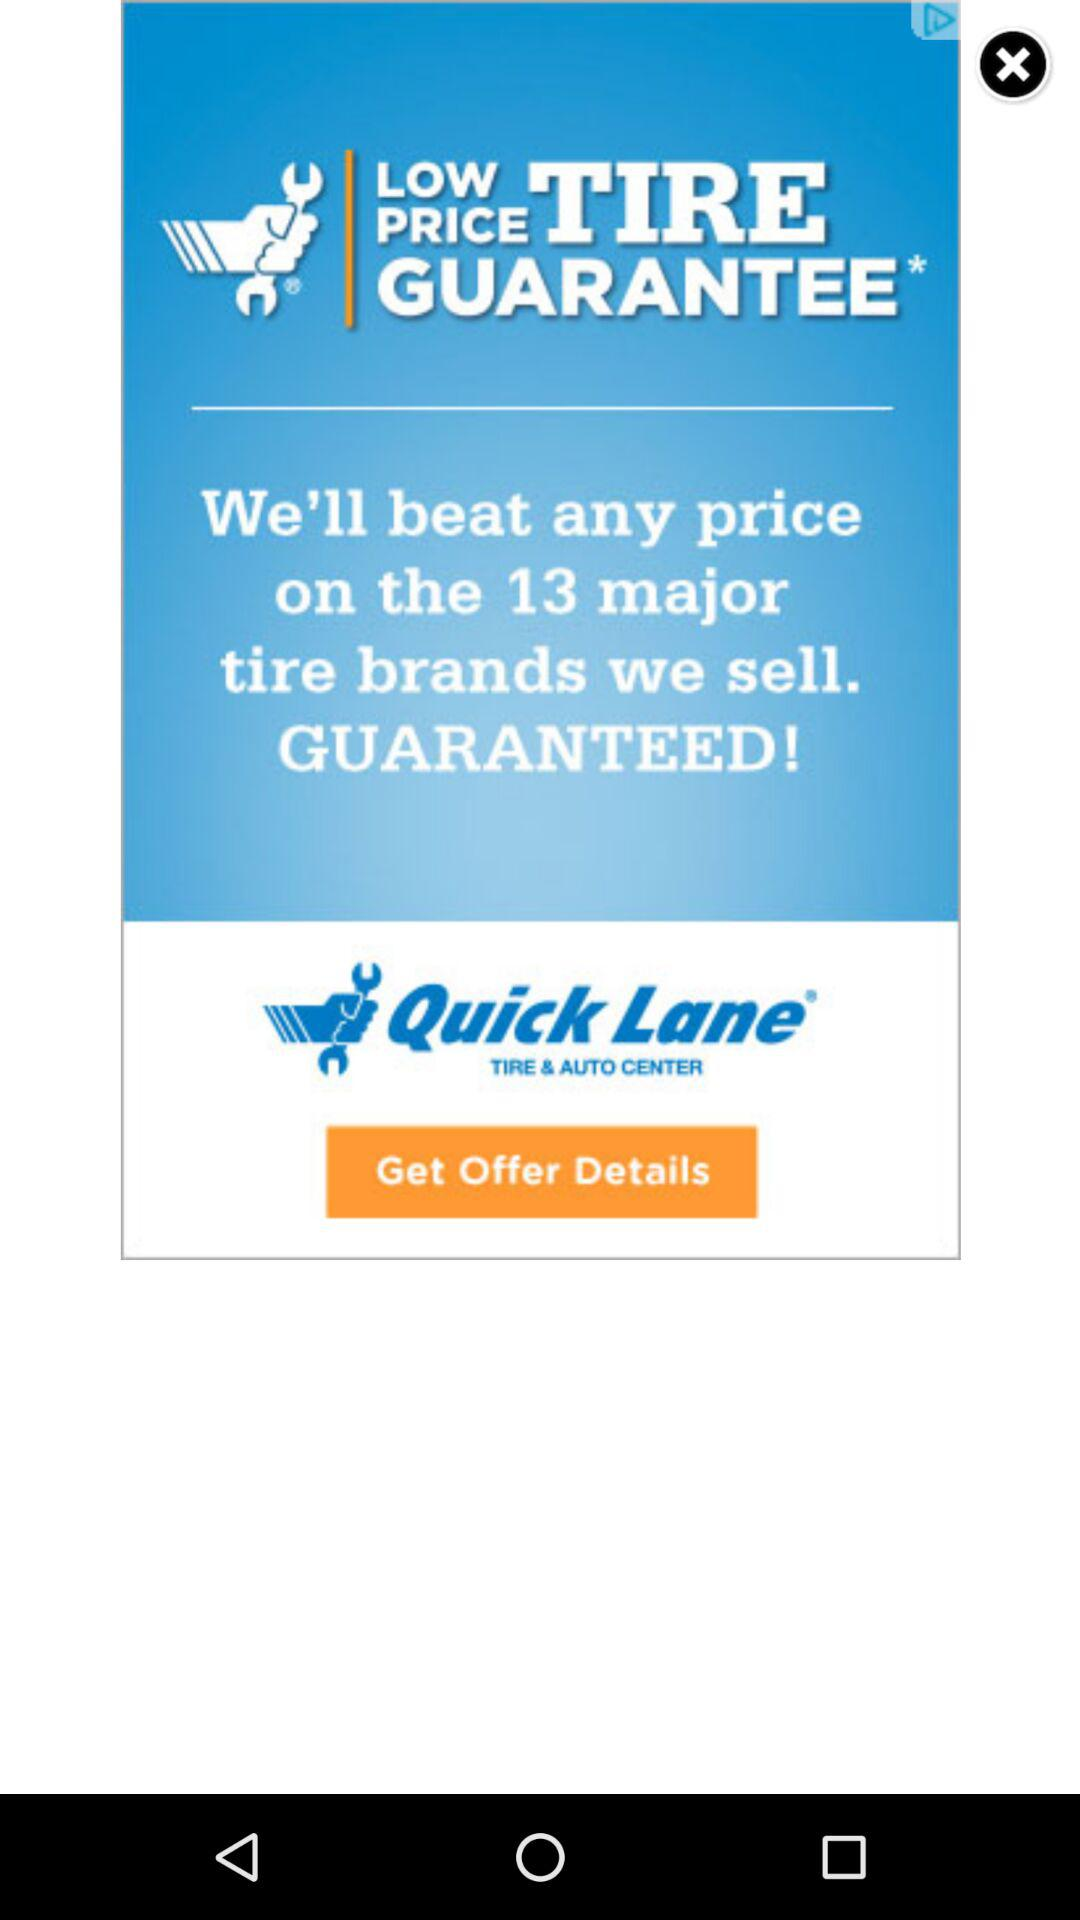How many brands of tires are covered by this guarantee?
Answer the question using a single word or phrase. 13 